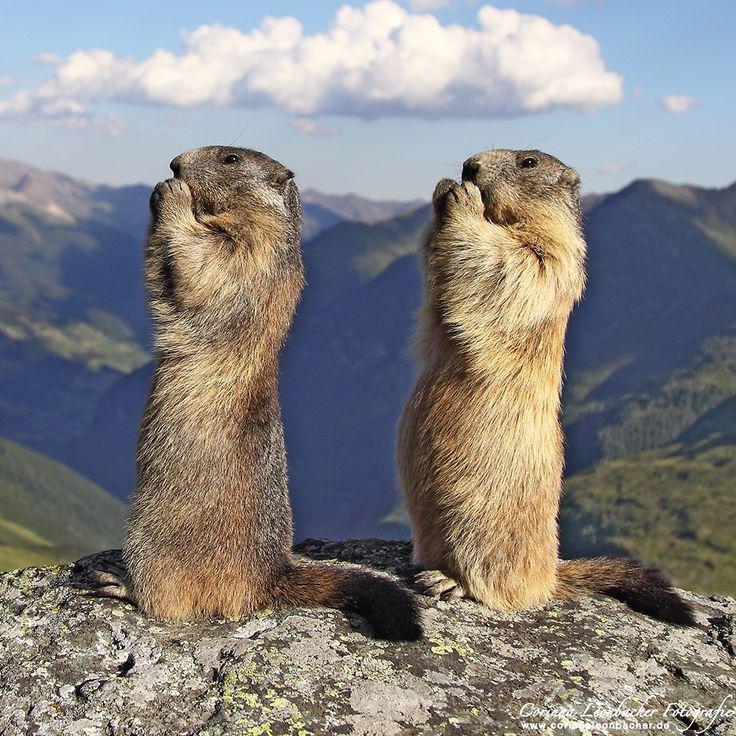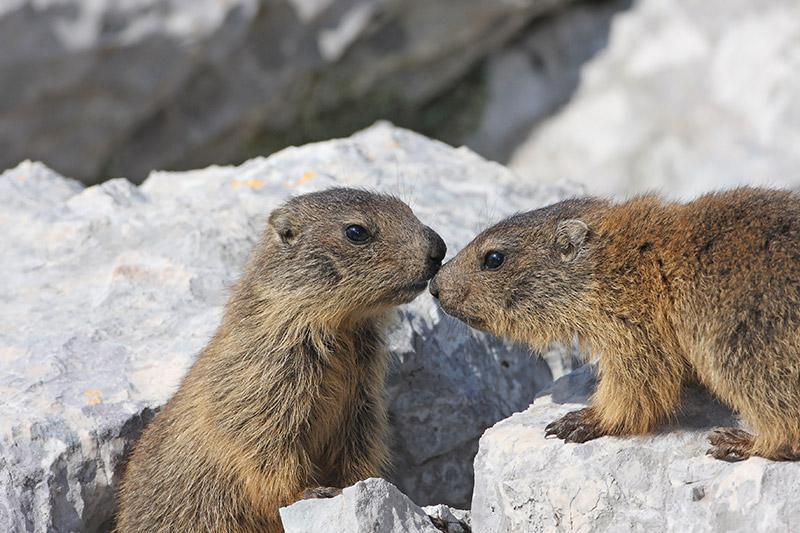The first image is the image on the left, the second image is the image on the right. Assess this claim about the two images: "There are 4 prairie dogs and 2 are up on their hind legs.". Correct or not? Answer yes or no. Yes. The first image is the image on the left, the second image is the image on the right. Given the left and right images, does the statement "There are at least 1 woodchuck poking its head out of the snow." hold true? Answer yes or no. No. 